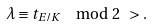Convert formula to latex. <formula><loc_0><loc_0><loc_500><loc_500>\lambda \equiv t _ { E / K } \mod 2 \ > .</formula> 